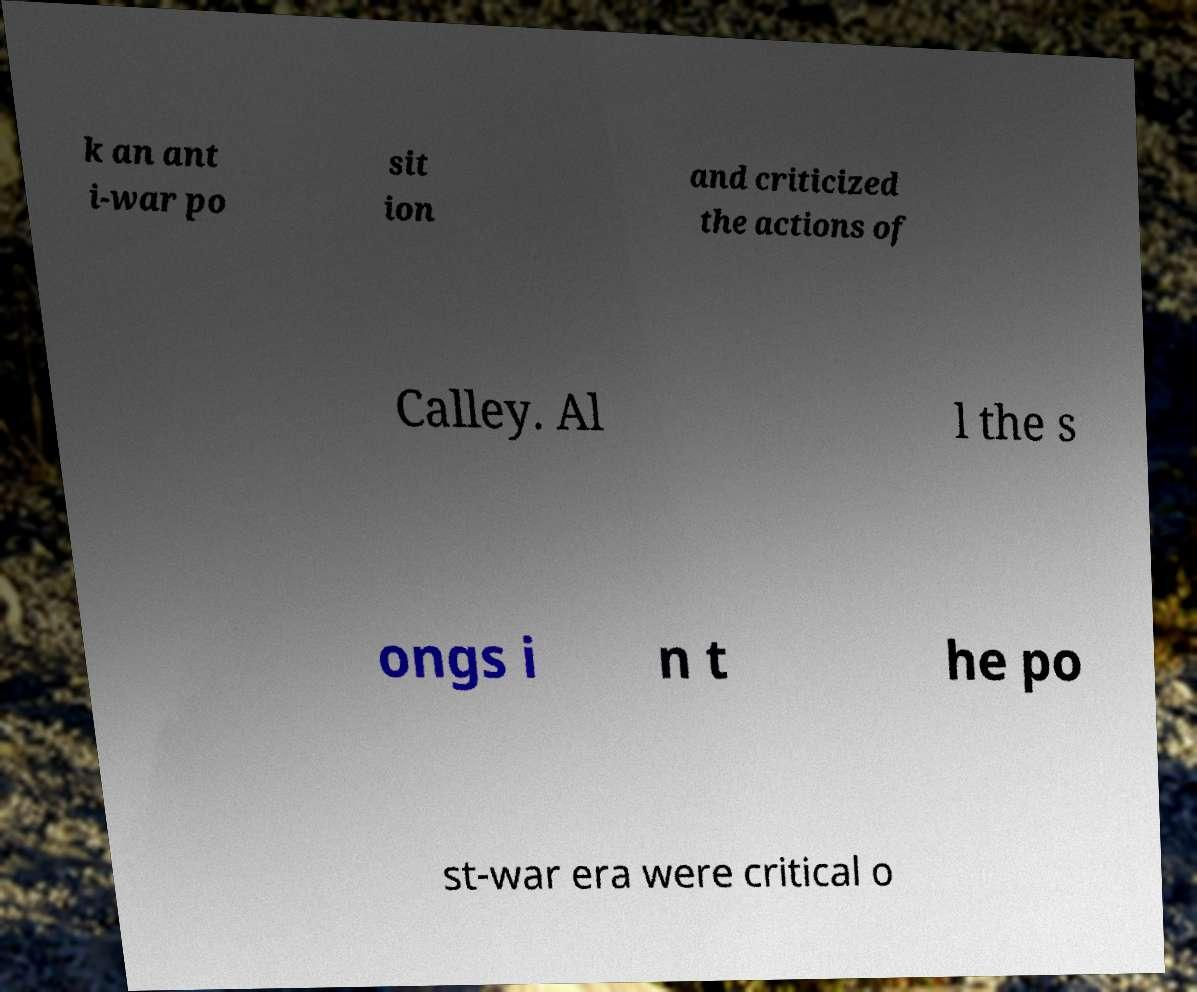I need the written content from this picture converted into text. Can you do that? k an ant i-war po sit ion and criticized the actions of Calley. Al l the s ongs i n t he po st-war era were critical o 